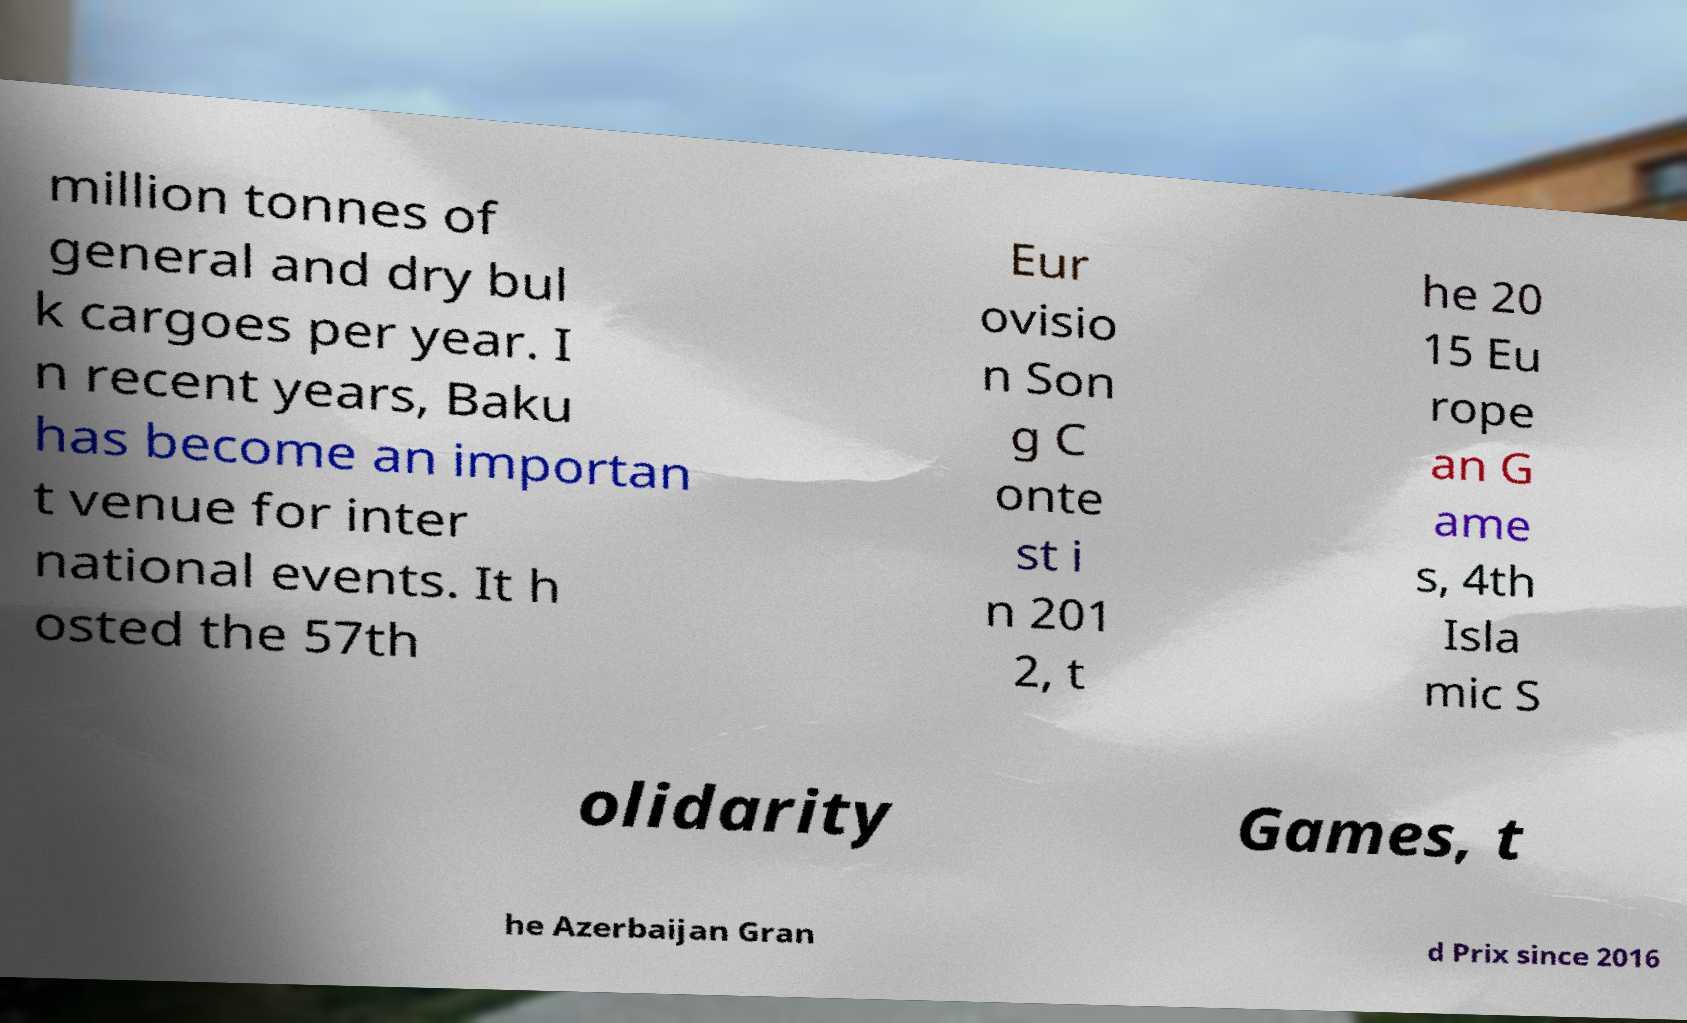Could you extract and type out the text from this image? million tonnes of general and dry bul k cargoes per year. I n recent years, Baku has become an importan t venue for inter national events. It h osted the 57th Eur ovisio n Son g C onte st i n 201 2, t he 20 15 Eu rope an G ame s, 4th Isla mic S olidarity Games, t he Azerbaijan Gran d Prix since 2016 